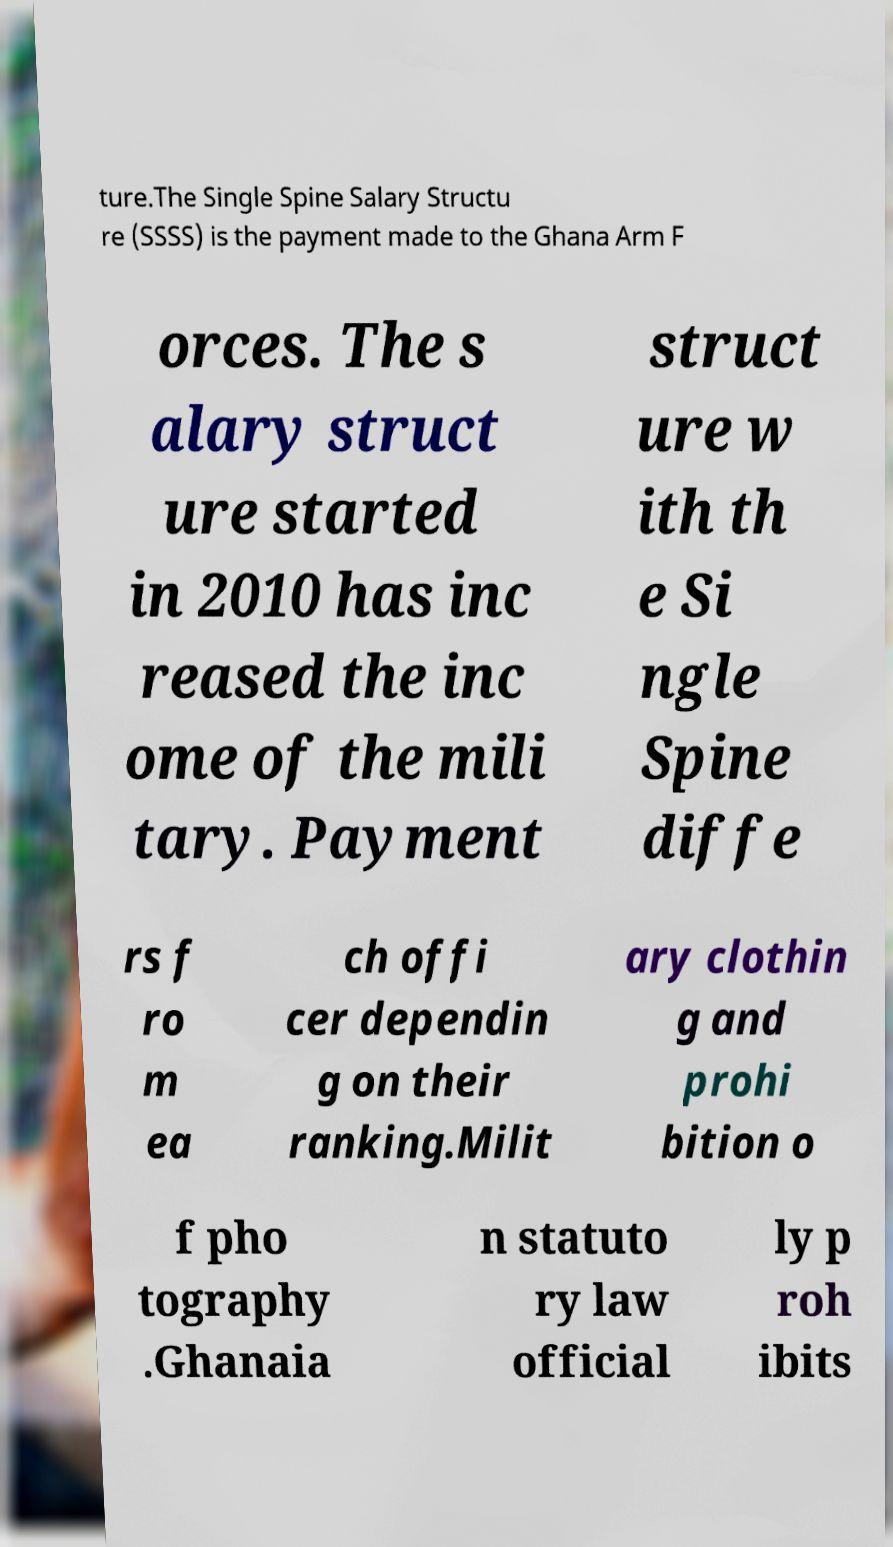Could you assist in decoding the text presented in this image and type it out clearly? ture.The Single Spine Salary Structu re (SSSS) is the payment made to the Ghana Arm F orces. The s alary struct ure started in 2010 has inc reased the inc ome of the mili tary. Payment struct ure w ith th e Si ngle Spine diffe rs f ro m ea ch offi cer dependin g on their ranking.Milit ary clothin g and prohi bition o f pho tography .Ghanaia n statuto ry law official ly p roh ibits 